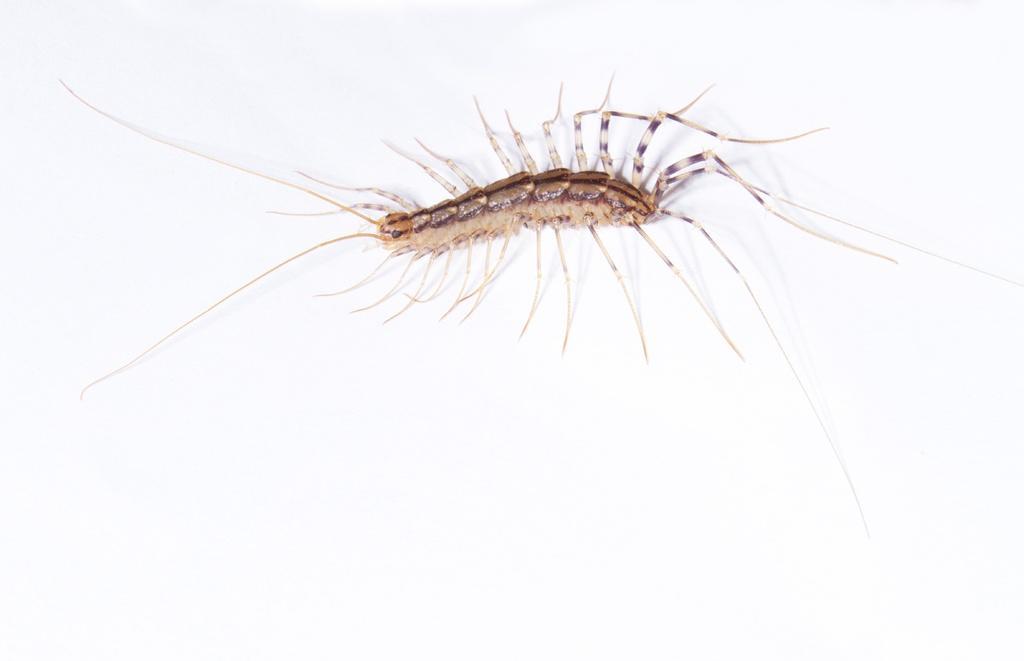Could you give a brief overview of what you see in this image? In this image I can see an insect on a white surface. 